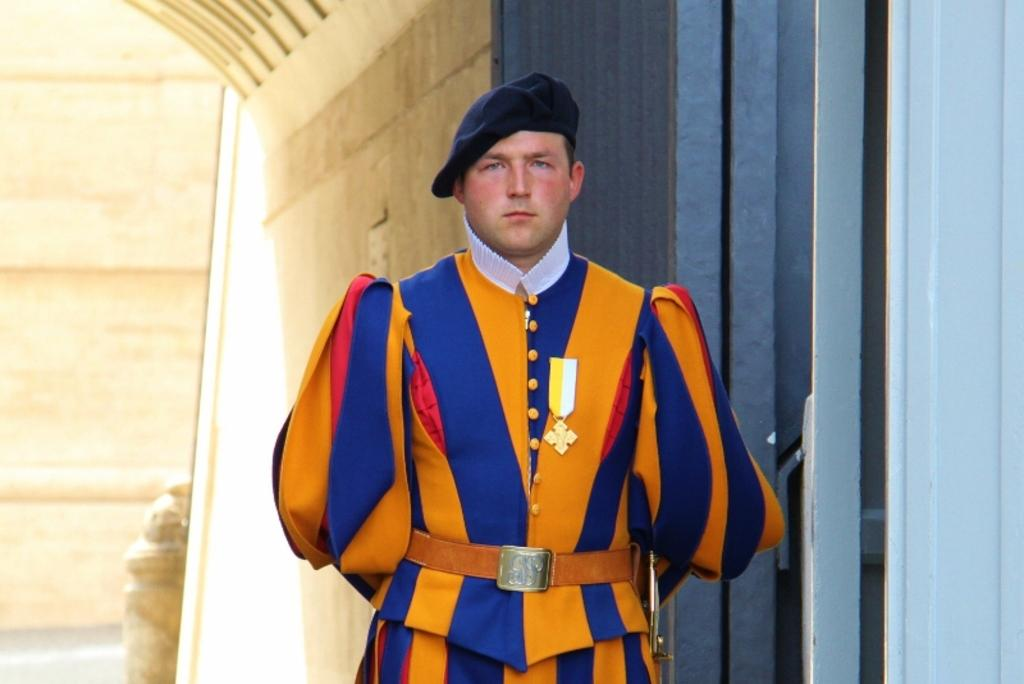What is the main subject of the image? There is a person standing in the center of the image. Can you describe the person's attire? The person is wearing a hat. What can be seen in the background of the image? There is a wall and a staircase in the background of the image, along with a few other objects. What type of quill is the scarecrow holding in the image? There is no scarecrow or quill present in the image. Is there any smoke visible in the image? There is no smoke visible in the image. 